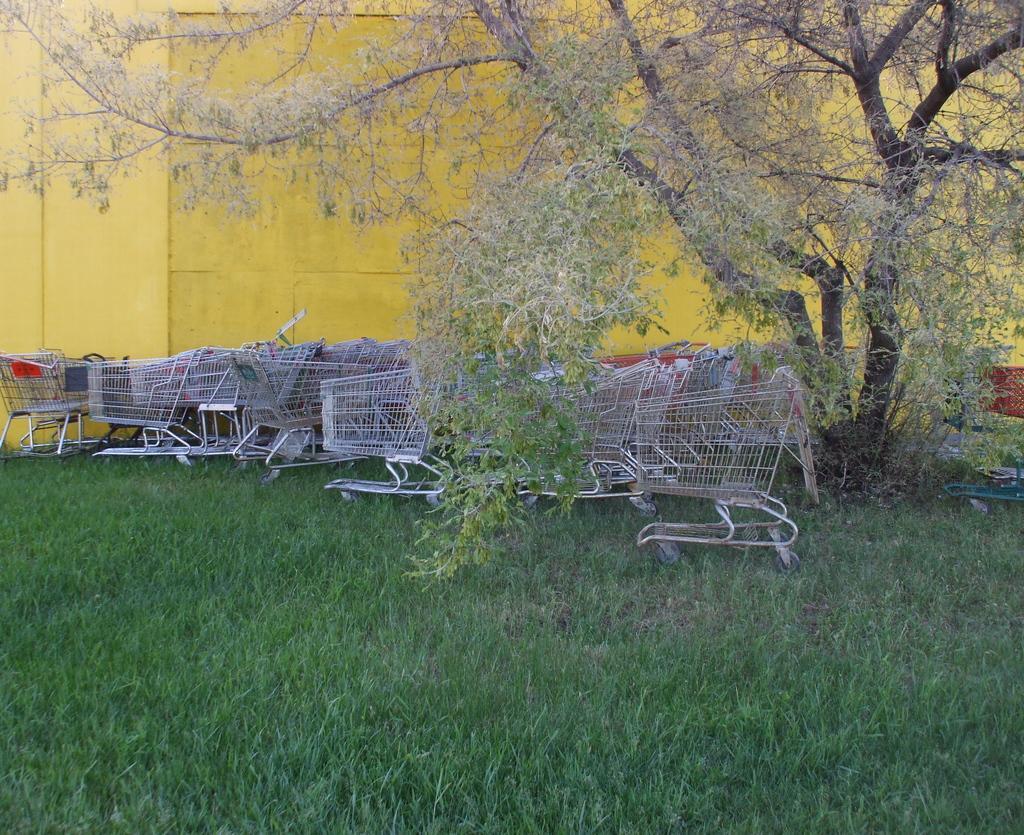Could you give a brief overview of what you see in this image? In this picture we can see silver shopping trolleys is the ground. In the front bottom side there is a grass lawn. Behind there is a tree and yellow wall. 